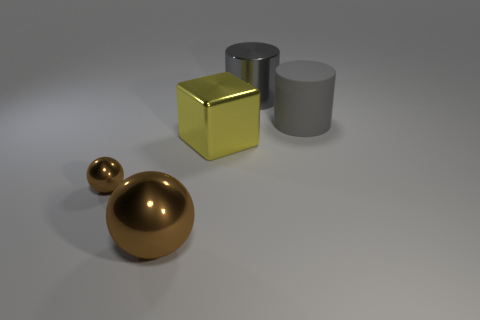What size is the metallic object that is the same color as the matte object?
Make the answer very short. Large. There is a shiny cylinder; are there any large cylinders on the left side of it?
Offer a terse response. No. What is the shape of the small brown shiny thing?
Offer a very short reply. Sphere. There is a brown metal object in front of the brown ball that is behind the metal sphere that is to the right of the tiny brown sphere; what shape is it?
Offer a very short reply. Sphere. What number of other things are there of the same shape as the big yellow metallic object?
Make the answer very short. 0. What material is the ball behind the brown object right of the small metallic object?
Keep it short and to the point. Metal. Is there anything else that has the same size as the metal cylinder?
Your answer should be compact. Yes. Do the tiny object and the big gray thing that is in front of the large metal cylinder have the same material?
Give a very brief answer. No. What is the thing that is behind the tiny object and in front of the rubber cylinder made of?
Provide a succinct answer. Metal. There is a cylinder behind the big cylinder that is right of the big gray metal thing; what color is it?
Make the answer very short. Gray. 